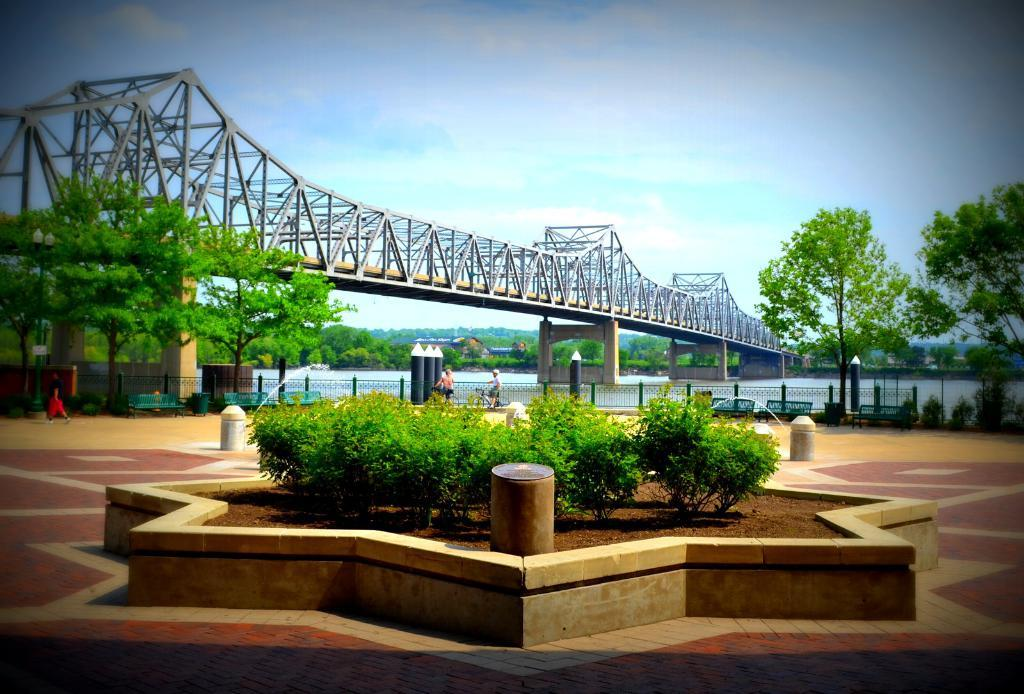What type of structure can be seen in the image? There is a bridge in the image. What is the surface that people or objects might be standing on or crossing in the image? There is a floor in the image. What type of vegetation is present in the image? There are plants and trees in the image. What type of barrier can be seen in the image? There is a fence in the image. What natural element is visible in the image? There is water visible in the image. What is visible at the top of the image? The sky is visible at the top of the image. Where is the lunchroom located in the image? There is no mention of a lunchroom in the image; it features a bridge, floor, plants, trees, fence, water, and sky. What shape is the square in the image? There is no square present in the image. 